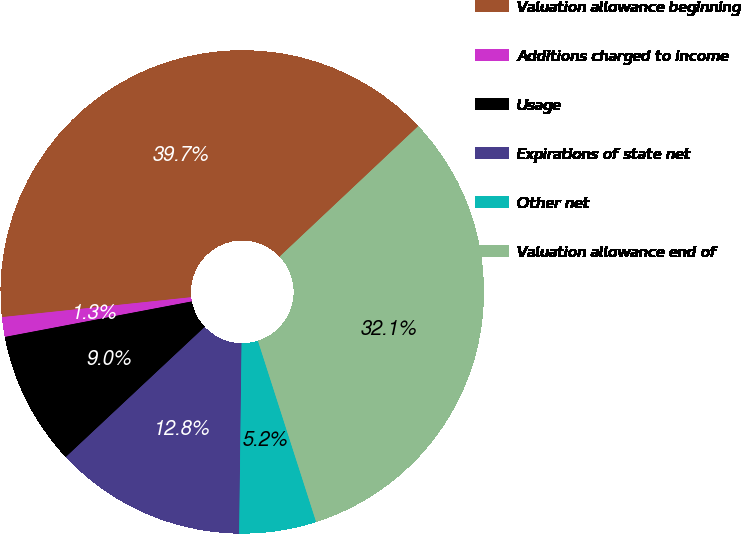<chart> <loc_0><loc_0><loc_500><loc_500><pie_chart><fcel>Valuation allowance beginning<fcel>Additions charged to income<fcel>Usage<fcel>Expirations of state net<fcel>Other net<fcel>Valuation allowance end of<nl><fcel>39.65%<fcel>1.32%<fcel>8.99%<fcel>12.82%<fcel>5.15%<fcel>32.07%<nl></chart> 